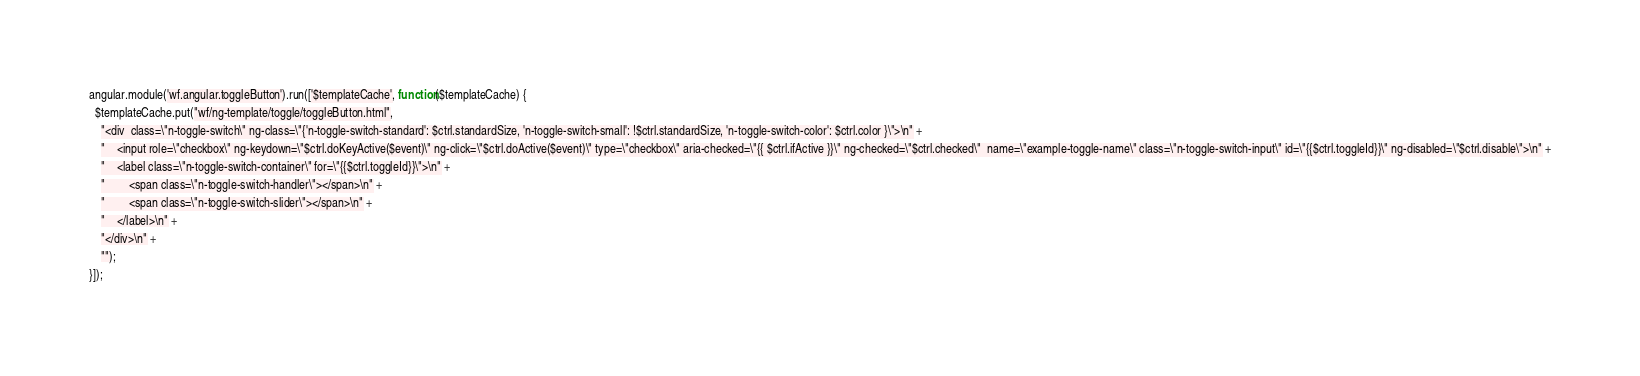<code> <loc_0><loc_0><loc_500><loc_500><_JavaScript_>angular.module('wf.angular.toggleButton').run(['$templateCache', function($templateCache) {
  $templateCache.put("wf/ng-template/toggle/toggleButton.html",
    "<div  class=\"n-toggle-switch\" ng-class=\"{'n-toggle-switch-standard': $ctrl.standardSize, 'n-toggle-switch-small': !$ctrl.standardSize, 'n-toggle-switch-color': $ctrl.color }\">\n" +
    "    <input role=\"checkbox\" ng-keydown=\"$ctrl.doKeyActive($event)\" ng-click=\"$ctrl.doActive($event)\" type=\"checkbox\" aria-checked=\"{{ $ctrl.ifActive }}\" ng-checked=\"$ctrl.checked\"  name=\"example-toggle-name\" class=\"n-toggle-switch-input\" id=\"{{$ctrl.toggleId}}\" ng-disabled=\"$ctrl.disable\">\n" +
    "    <label class=\"n-toggle-switch-container\" for=\"{{$ctrl.toggleId}}\">\n" +
    "        <span class=\"n-toggle-switch-handler\"></span>\n" +
    "        <span class=\"n-toggle-switch-slider\"></span>\n" +
    "    </label>\n" +
    "</div>\n" +
    "");
}]);
</code> 